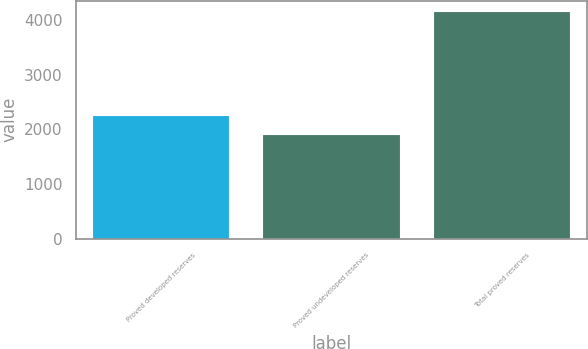Convert chart to OTSL. <chart><loc_0><loc_0><loc_500><loc_500><bar_chart><fcel>Proved developed reserves<fcel>Proved undeveloped reserves<fcel>Total proved reserves<nl><fcel>2252<fcel>1891<fcel>4143<nl></chart> 